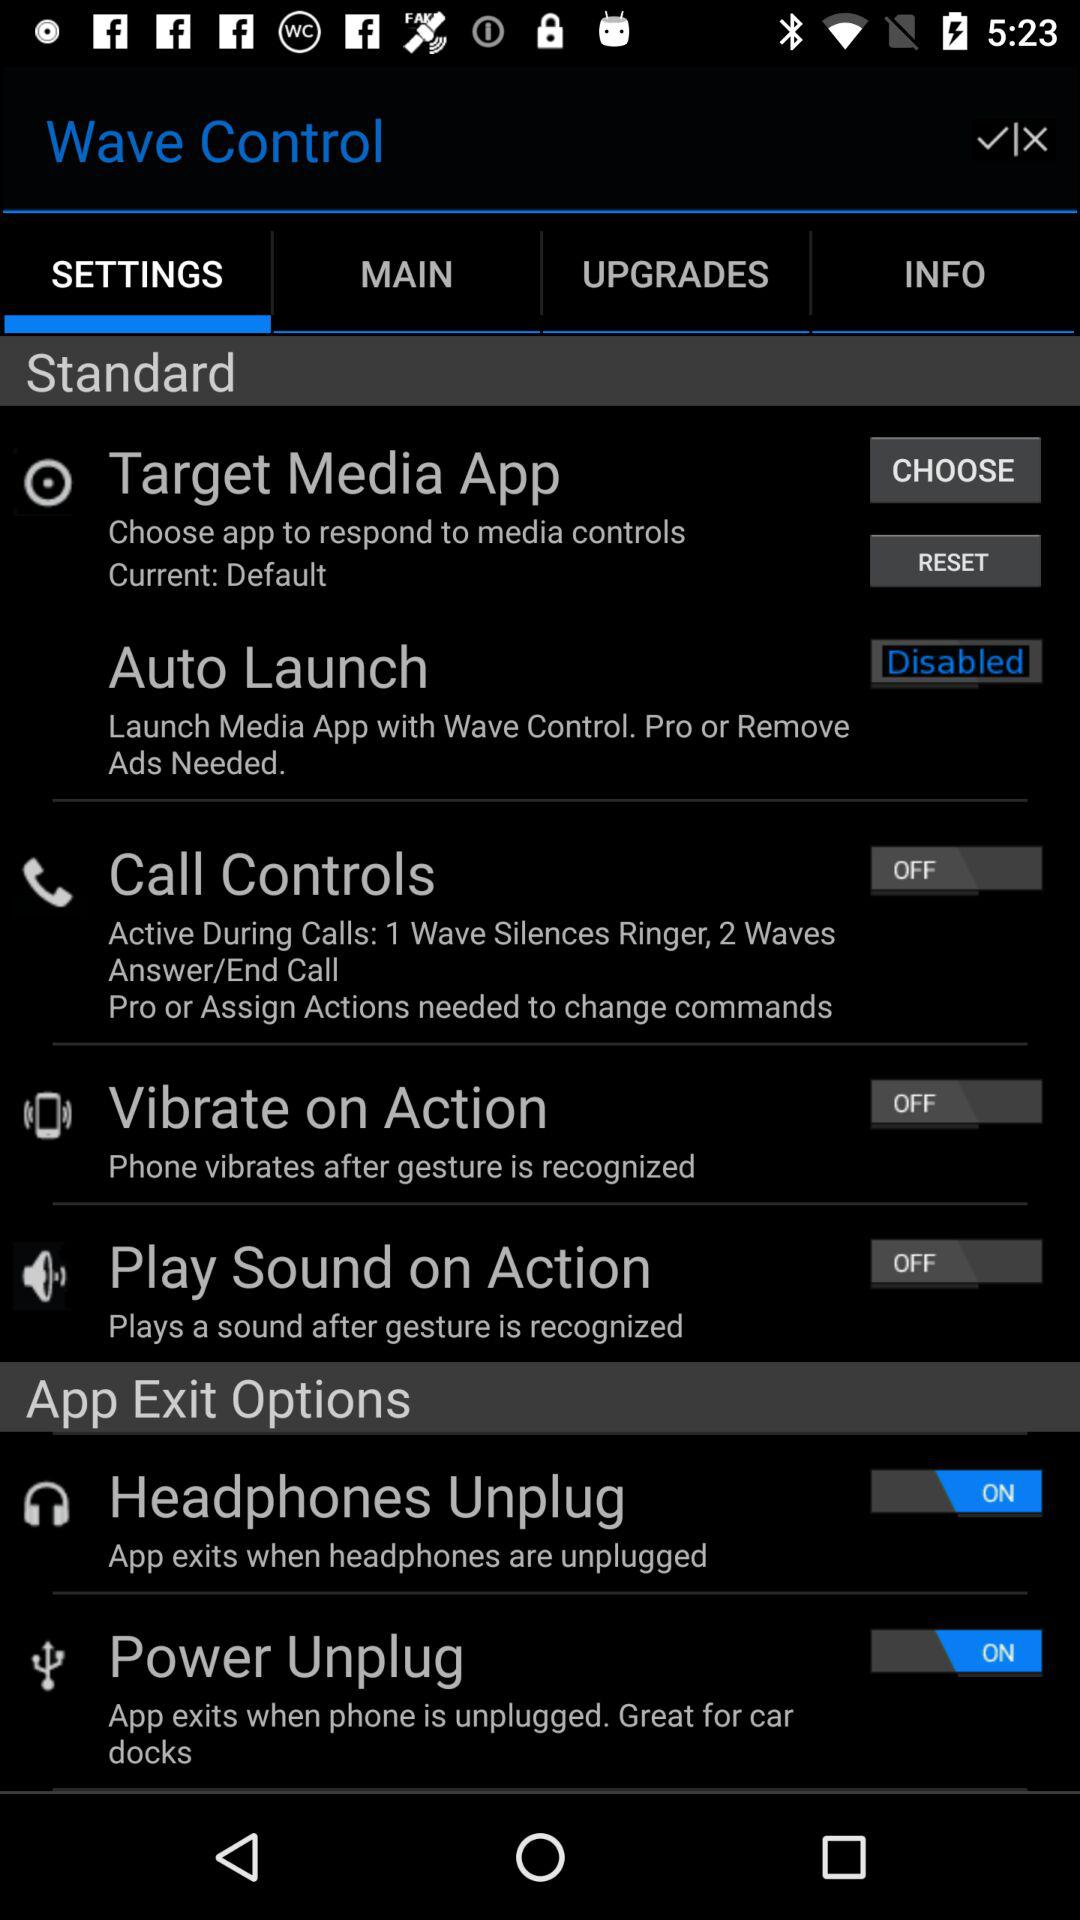How many of the app exit options have switches? 2 